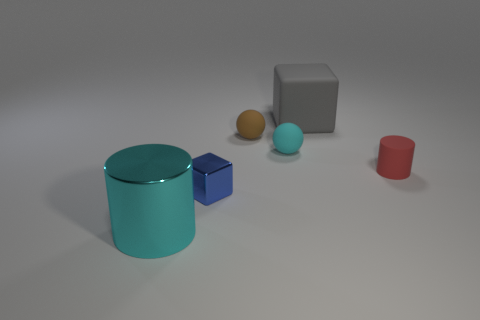There is a matte object on the right side of the big object to the right of the cylinder that is on the left side of the large gray rubber object; what is its size?
Offer a very short reply. Small. What size is the object that is both behind the small cyan rubber object and in front of the large rubber object?
Give a very brief answer. Small. The cyan object that is to the right of the big object that is in front of the red thing is what shape?
Ensure brevity in your answer.  Sphere. Is there any other thing that is the same color as the large shiny object?
Provide a short and direct response. Yes. The thing that is left of the metal block has what shape?
Offer a terse response. Cylinder. What shape is the object that is right of the brown ball and behind the small cyan rubber thing?
Make the answer very short. Cube. How many gray things are either large shiny balls or tiny metal objects?
Offer a terse response. 0. Is the color of the rubber ball on the right side of the small brown ball the same as the big shiny thing?
Make the answer very short. Yes. How big is the matte sphere to the left of the rubber ball on the right side of the brown rubber object?
Give a very brief answer. Small. There is a cube that is the same size as the cyan matte object; what material is it?
Your response must be concise. Metal. 